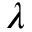<formula> <loc_0><loc_0><loc_500><loc_500>\lambda</formula> 